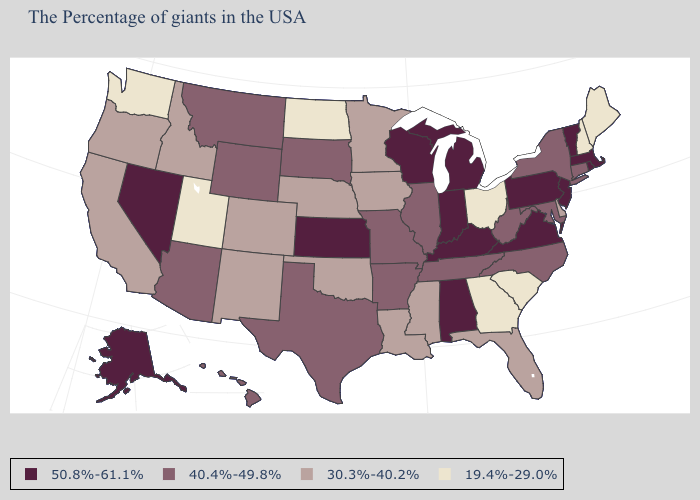What is the value of New Hampshire?
Keep it brief. 19.4%-29.0%. Name the states that have a value in the range 19.4%-29.0%?
Concise answer only. Maine, New Hampshire, South Carolina, Ohio, Georgia, North Dakota, Utah, Washington. Is the legend a continuous bar?
Short answer required. No. Does the first symbol in the legend represent the smallest category?
Write a very short answer. No. Name the states that have a value in the range 19.4%-29.0%?
Answer briefly. Maine, New Hampshire, South Carolina, Ohio, Georgia, North Dakota, Utah, Washington. What is the value of Tennessee?
Quick response, please. 40.4%-49.8%. Which states hav the highest value in the MidWest?
Be succinct. Michigan, Indiana, Wisconsin, Kansas. Name the states that have a value in the range 40.4%-49.8%?
Write a very short answer. Connecticut, New York, Maryland, North Carolina, West Virginia, Tennessee, Illinois, Missouri, Arkansas, Texas, South Dakota, Wyoming, Montana, Arizona, Hawaii. Is the legend a continuous bar?
Be succinct. No. What is the highest value in states that border Utah?
Quick response, please. 50.8%-61.1%. Name the states that have a value in the range 50.8%-61.1%?
Concise answer only. Massachusetts, Rhode Island, Vermont, New Jersey, Pennsylvania, Virginia, Michigan, Kentucky, Indiana, Alabama, Wisconsin, Kansas, Nevada, Alaska. What is the value of New Mexico?
Concise answer only. 30.3%-40.2%. Name the states that have a value in the range 30.3%-40.2%?
Give a very brief answer. Delaware, Florida, Mississippi, Louisiana, Minnesota, Iowa, Nebraska, Oklahoma, Colorado, New Mexico, Idaho, California, Oregon. Which states have the lowest value in the USA?
Write a very short answer. Maine, New Hampshire, South Carolina, Ohio, Georgia, North Dakota, Utah, Washington. Does Mississippi have a higher value than Colorado?
Keep it brief. No. 